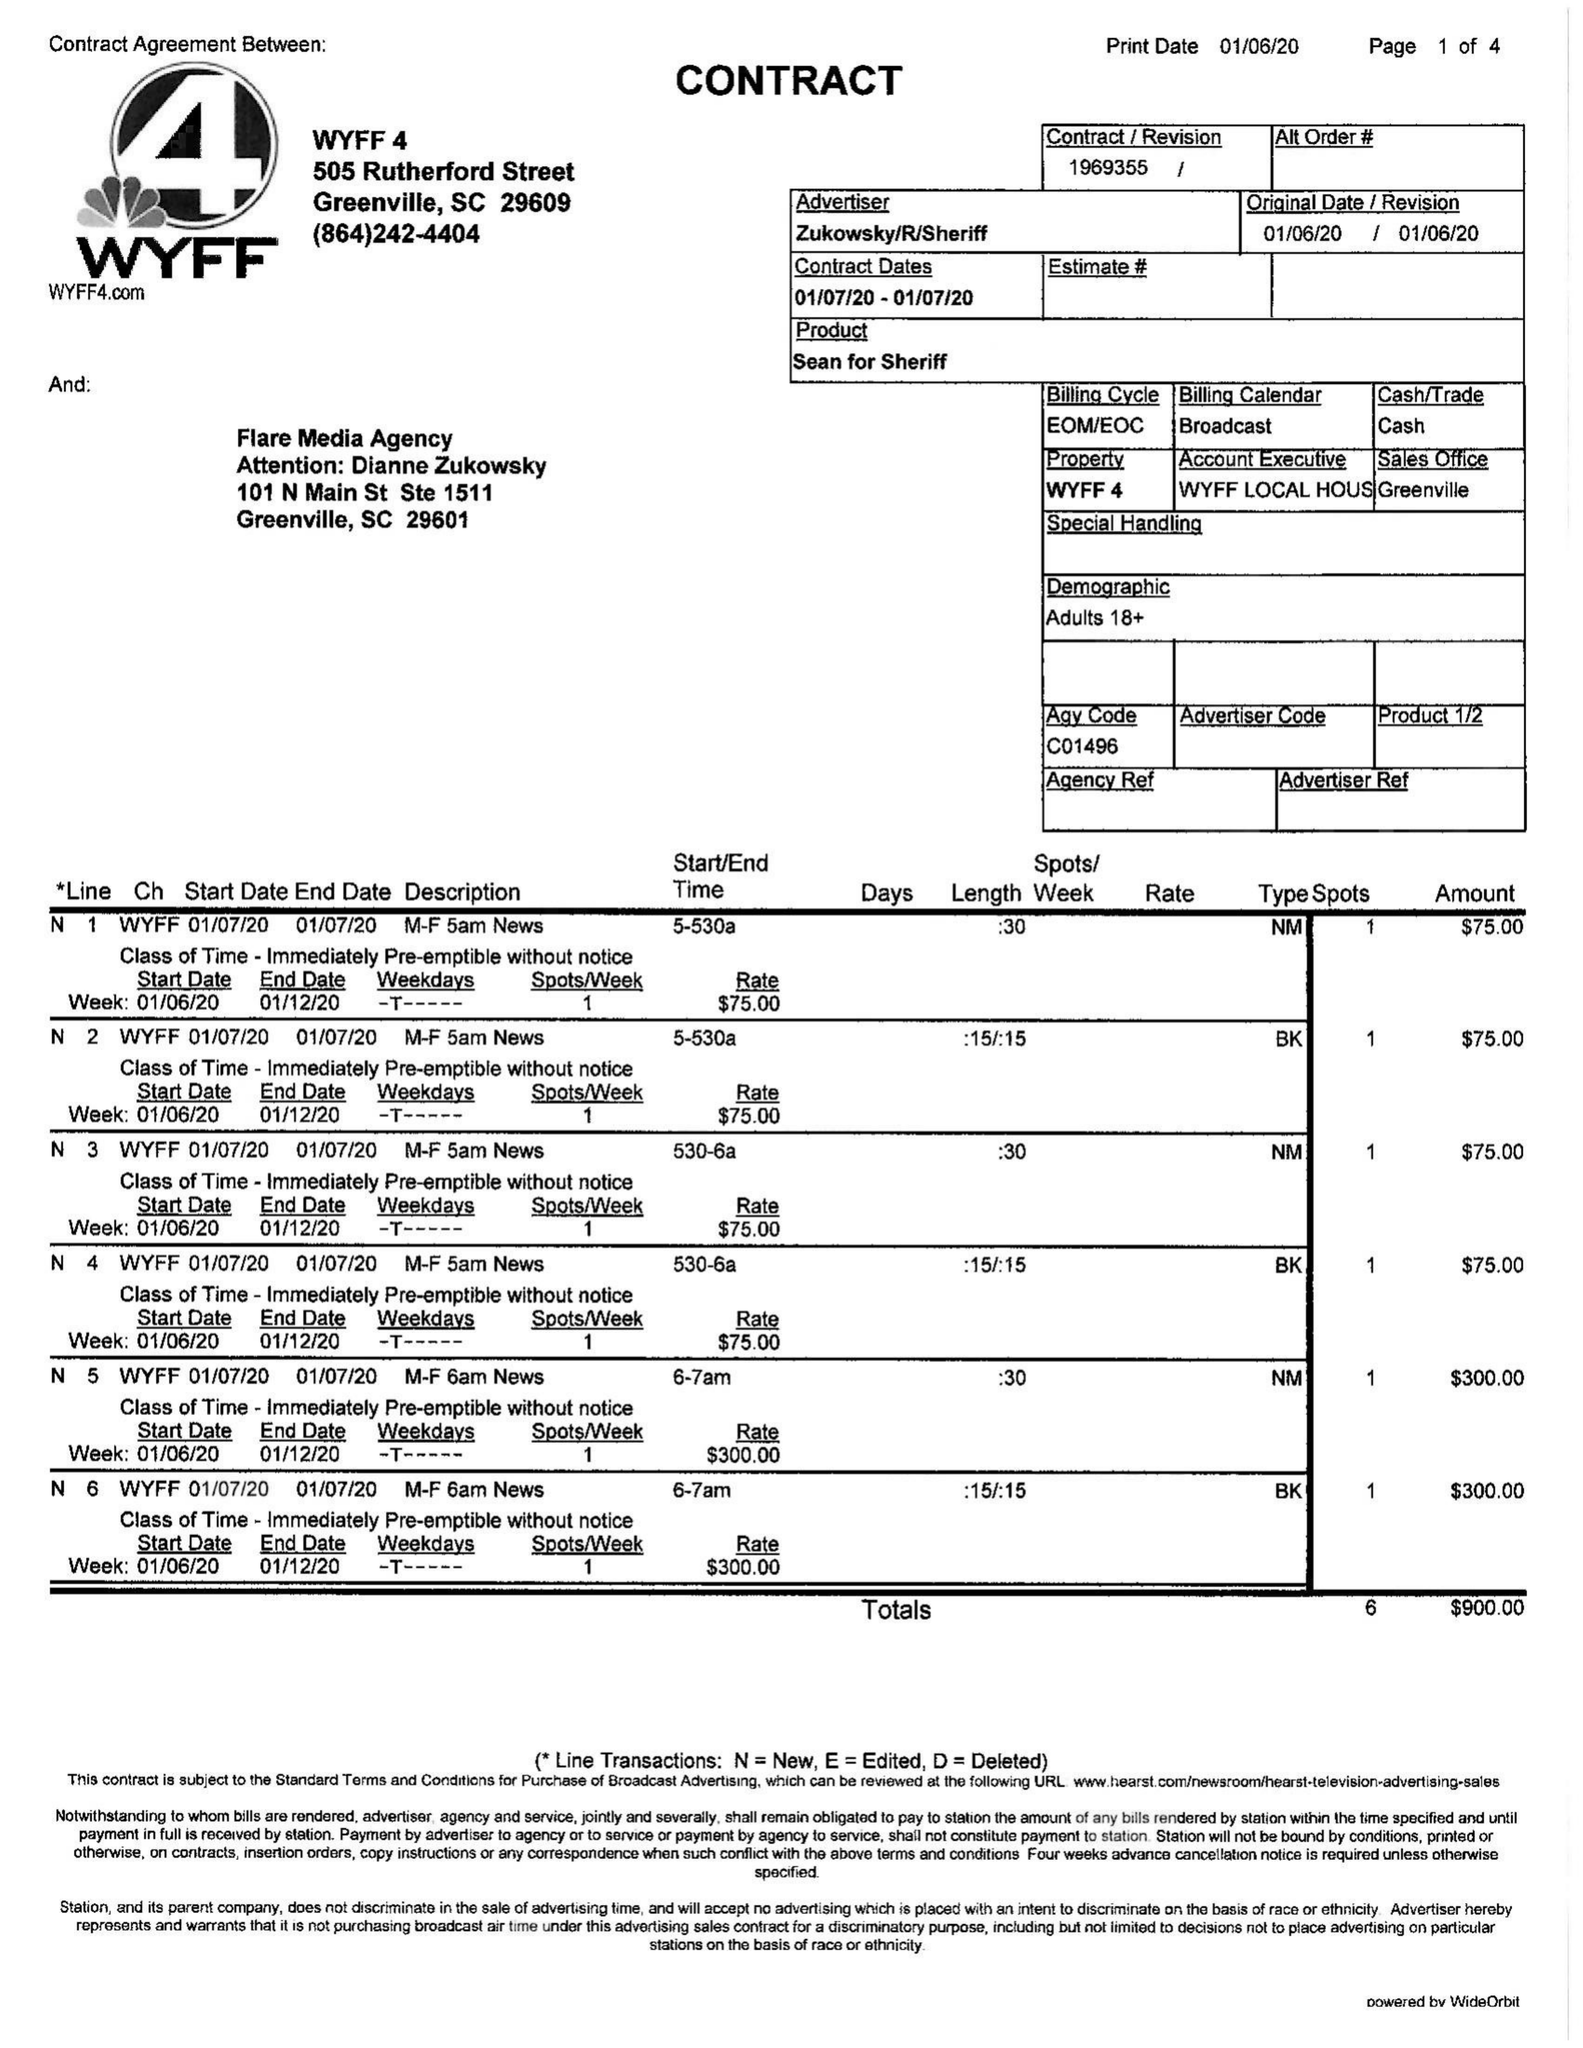What is the value for the contract_num?
Answer the question using a single word or phrase. 1969355 